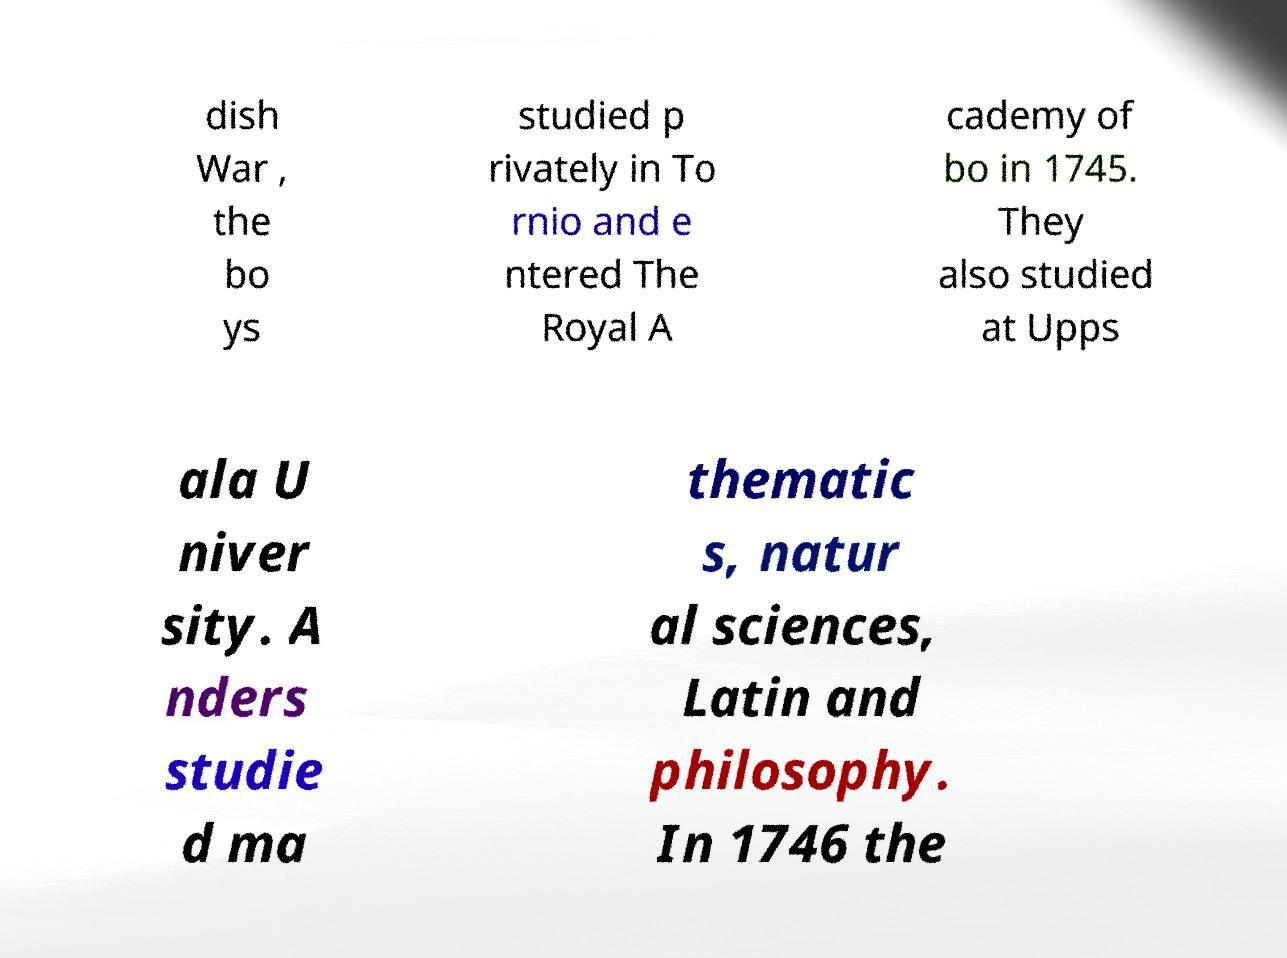Can you accurately transcribe the text from the provided image for me? dish War , the bo ys studied p rivately in To rnio and e ntered The Royal A cademy of bo in 1745. They also studied at Upps ala U niver sity. A nders studie d ma thematic s, natur al sciences, Latin and philosophy. In 1746 the 